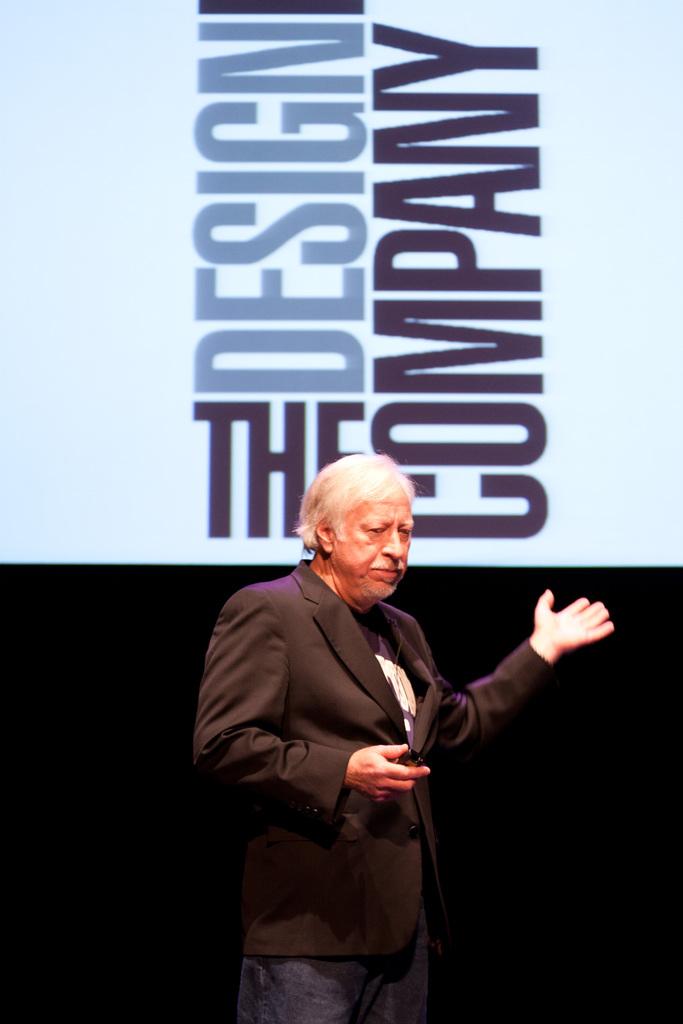What is the graphics firm's name that started in may 1978?
Your answer should be very brief. The design company. 